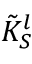<formula> <loc_0><loc_0><loc_500><loc_500>\tilde { K } _ { S } ^ { l }</formula> 